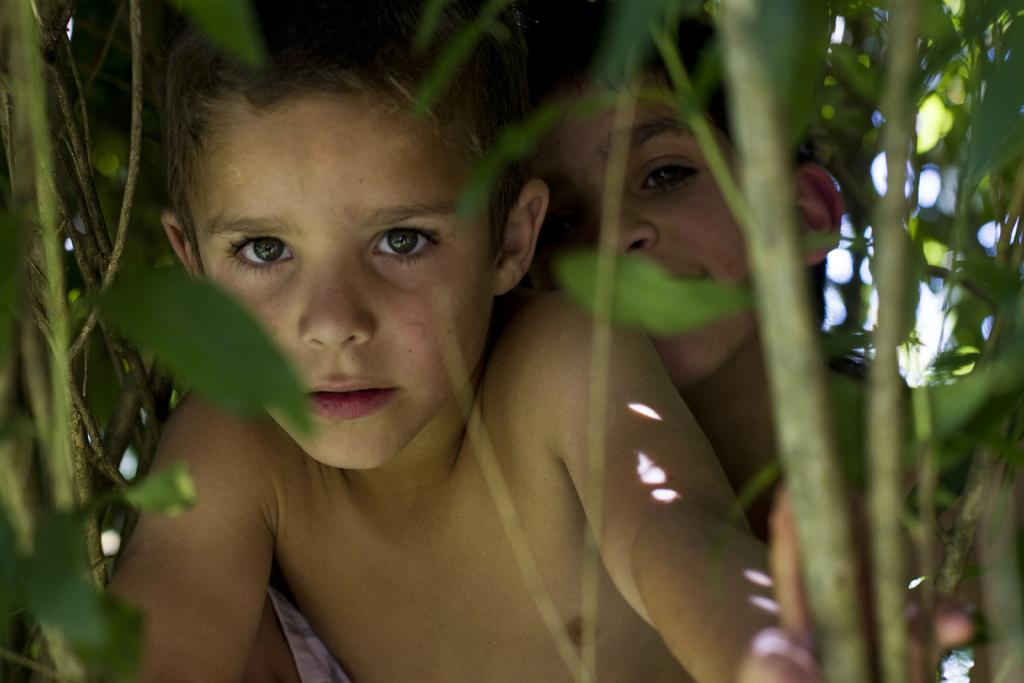What type of living organisms can be seen in the image? Plants can be seen in the image. What else is present in the image besides plants? There are kids in the middle of the image. What type of humor can be seen in the image? There is no humor present in the image; it features plants and kids. Can you find a match in the image? There is no match present in the image. 